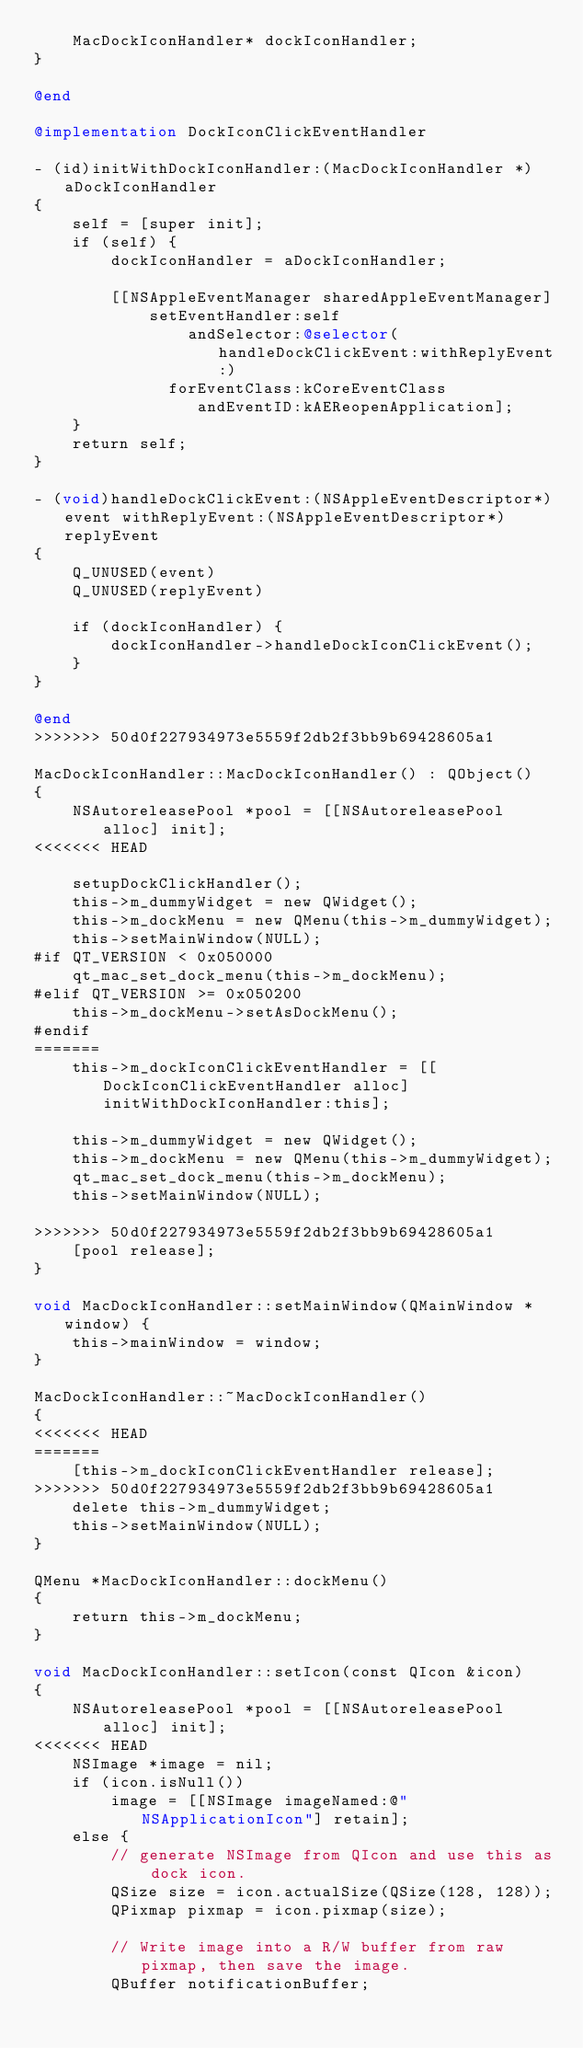<code> <loc_0><loc_0><loc_500><loc_500><_ObjectiveC_>    MacDockIconHandler* dockIconHandler;
}

@end

@implementation DockIconClickEventHandler

- (id)initWithDockIconHandler:(MacDockIconHandler *)aDockIconHandler
{
    self = [super init];
    if (self) {
        dockIconHandler = aDockIconHandler;

        [[NSAppleEventManager sharedAppleEventManager]
            setEventHandler:self
                andSelector:@selector(handleDockClickEvent:withReplyEvent:)
              forEventClass:kCoreEventClass
                 andEventID:kAEReopenApplication];
    }
    return self;
}

- (void)handleDockClickEvent:(NSAppleEventDescriptor*)event withReplyEvent:(NSAppleEventDescriptor*)replyEvent
{
    Q_UNUSED(event)
    Q_UNUSED(replyEvent)

    if (dockIconHandler) {
        dockIconHandler->handleDockIconClickEvent();
    }
}

@end
>>>>>>> 50d0f227934973e5559f2db2f3bb9b69428605a1

MacDockIconHandler::MacDockIconHandler() : QObject()
{
    NSAutoreleasePool *pool = [[NSAutoreleasePool alloc] init];
<<<<<<< HEAD

    setupDockClickHandler();
    this->m_dummyWidget = new QWidget();
    this->m_dockMenu = new QMenu(this->m_dummyWidget);
    this->setMainWindow(NULL);
#if QT_VERSION < 0x050000
    qt_mac_set_dock_menu(this->m_dockMenu);
#elif QT_VERSION >= 0x050200
    this->m_dockMenu->setAsDockMenu();
#endif
=======
    this->m_dockIconClickEventHandler = [[DockIconClickEventHandler alloc] initWithDockIconHandler:this];

    this->m_dummyWidget = new QWidget();
    this->m_dockMenu = new QMenu(this->m_dummyWidget);
    qt_mac_set_dock_menu(this->m_dockMenu);
    this->setMainWindow(NULL);

>>>>>>> 50d0f227934973e5559f2db2f3bb9b69428605a1
    [pool release];
}

void MacDockIconHandler::setMainWindow(QMainWindow *window) {
    this->mainWindow = window;
}

MacDockIconHandler::~MacDockIconHandler()
{
<<<<<<< HEAD
=======
    [this->m_dockIconClickEventHandler release];
>>>>>>> 50d0f227934973e5559f2db2f3bb9b69428605a1
    delete this->m_dummyWidget;
    this->setMainWindow(NULL);
}

QMenu *MacDockIconHandler::dockMenu()
{
    return this->m_dockMenu;
}

void MacDockIconHandler::setIcon(const QIcon &icon)
{
    NSAutoreleasePool *pool = [[NSAutoreleasePool alloc] init];
<<<<<<< HEAD
    NSImage *image = nil;
    if (icon.isNull())
        image = [[NSImage imageNamed:@"NSApplicationIcon"] retain];
    else {
        // generate NSImage from QIcon and use this as dock icon.
        QSize size = icon.actualSize(QSize(128, 128));
        QPixmap pixmap = icon.pixmap(size);

        // Write image into a R/W buffer from raw pixmap, then save the image.
        QBuffer notificationBuffer;</code> 